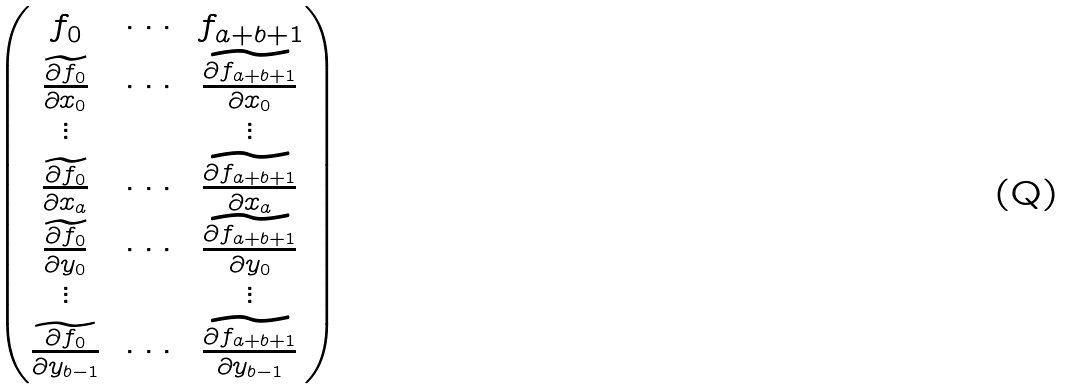Convert formula to latex. <formula><loc_0><loc_0><loc_500><loc_500>\begin{pmatrix} f _ { 0 } & \, \cdots \, & f _ { a + b + 1 } \\ \widetilde { \frac { \partial f _ { 0 } } { \partial x _ { 0 } } } & \, \cdots \, & \widetilde { \frac { \partial f _ { a + b + 1 } } { \partial x _ { 0 } } } \\ \vdots & & \vdots \\ \widetilde { \frac { \partial f _ { 0 } } { \partial x _ { a } } } & \, \cdots \, & \widetilde { \frac { \partial f _ { a + b + 1 } } { \partial x _ { a } } } \\ \widetilde { \frac { \partial f _ { 0 } } { \partial y _ { 0 } } } & \, \cdots \, & \widetilde { \frac { \partial f _ { a + b + 1 } } { \partial y _ { 0 } } } \\ \vdots & & \vdots \\ \widetilde { \frac { \partial f _ { 0 } } { \partial y _ { b - 1 } } } & \, \cdots \, & \widetilde { \frac { \partial f _ { a + b + 1 } } { \partial y _ { b - 1 } } } \end{pmatrix}</formula> 